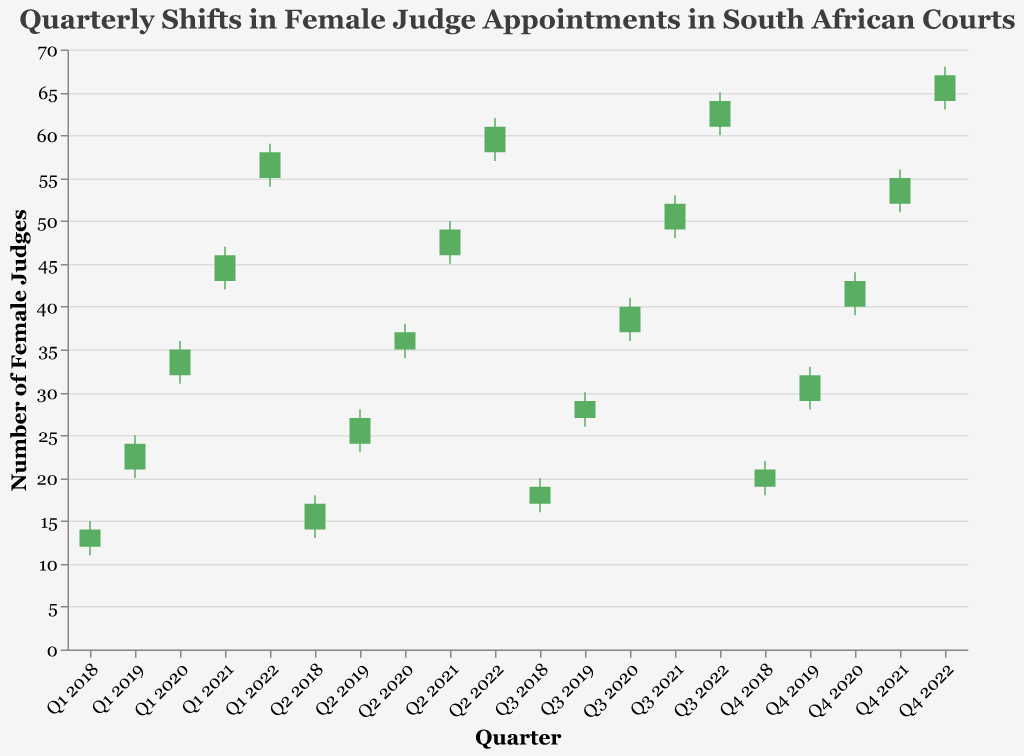What is the title of the chart? The title of the chart is usually displayed at the top of the figure. For this OHLC chart, the title is "Quarterly Shifts in Female Judge Appointments in South African Courts".
Answer: Quarterly Shifts in Female Judge Appointments in South African Courts Which quarter had the highest number of appointments at the close? The highest number of appointments at the close occurs where the y-axis value for the Close field is at its maximum. The highest Close value in the data is 67 for Q4 2022.
Answer: Q4 2022 By how many judges did the number of female appointments increase from Q1 2018 to Q4 2022? To find the increase, subtract the number of female judges at the start (Q1 2018 Close value 14) from the number at the end (Q4 2022 Close value 67). 67 - 14 = 53
Answer: 53 Which quarter had the smallest range between the lowest and highest number of appointments? To find the smallest range, subtract the Low value from the High value for each quarter and identify the minimum. The smallest range is 3 (High 15 - Low 11) for Q1 2018.
Answer: Q1 2018 In which quarter of 2020 did the number of female judges increase the most? To determine this, compare the Close values and find the largest increase. From Q1 2020 (Close 35) to Q2 2020 (Close 37), Q2 2020 to Q3 2020 (Close 40), and Q3 2020 to Q4 2020 (Close 43), the largest increase is from Q3 to Q4 (40 to 43).
Answer: Q4 2020 What is the trend in the number of female judge appointments from Q1 2018 to Q4 2022? Observing the chart, the overall trend can be characterized as consistently increasing from Q1 2018 (Close 14) to Q4 2022 (Close 67).
Answer: Increasing How many data points show a decrease in the number of appointments from Open to Close in a quarter? Compare each quarter's Open and Close values. If Open > Close, it's a decrease. Only two decreases are identified in the data (Q2 2022 and Q3 2022).
Answer: 2 Which quarter shows the greatest fluctuation in the number of appointments? Determine the greatest fluctuation by identifying the maximum difference between High and Low. The largest difference is 4 (Q4 2020 and Q2 2021, both with High-Low values of 44-39 and 50-45, respectively.
Answer: Q4 2020 and Q2 2021 Compare Q1 2019 and Q1 2020. In which quarter was the increase in female judge appointments larger from the open to the close? Calculate the difference between Open and Close for both quarters. Q1 2019 (Close 24 - Open 21 = 3) and Q1 2020 (Close 35 - Open 32 = 3). Both quarters show an increase of 3.
Answer: Equal, both increased by 3 What is the average number of female judge appointments at the close for the year 2019? Add the Close values for all quarters in 2019 (24, 27, 29, 32), then divide by the number of quarters (4). So (24 + 27 + 29 + 32) / 4 = 112 / 4 = 28
Answer: 28 